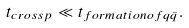Convert formula to latex. <formula><loc_0><loc_0><loc_500><loc_500>t _ { c r o s s p } \ll t _ { f o r m a t i o n o f q \bar { q } } .</formula> 